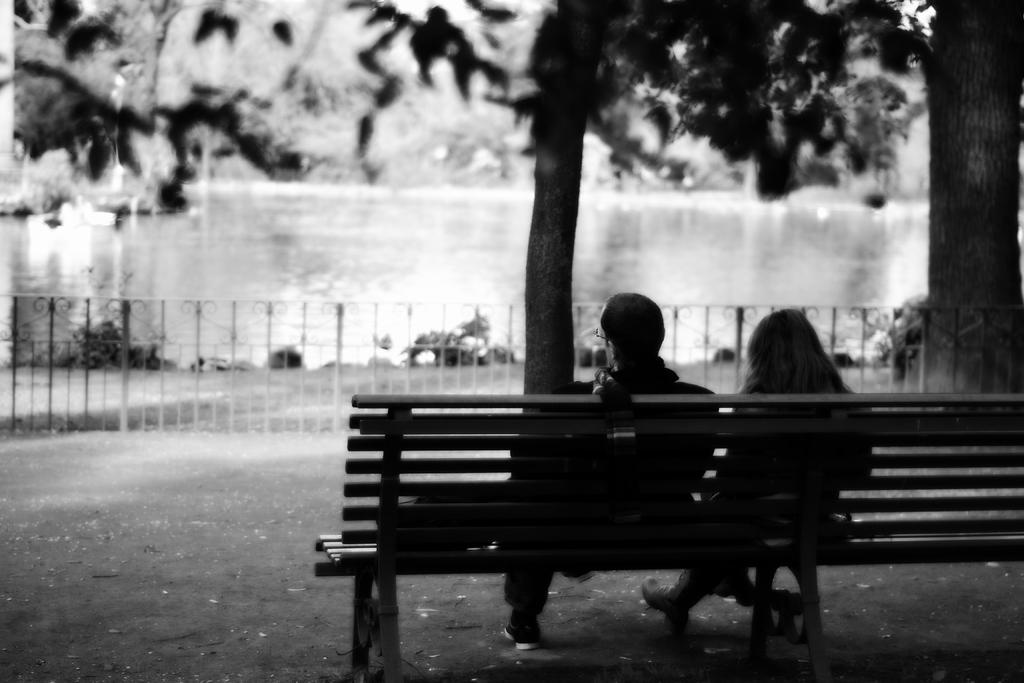How many people are in the image? There are two people in the image: a man and a woman. What are the man and woman doing in the image? The man and woman are sitting on a bench. What can be seen in the background of the image? There are trees, a lake, and plants in the background of the image. What type of badge is the man wearing in the image? There is no badge visible on the man in the image. How many muscles can be seen flexing on the woman's arm in the image? There are no muscles flexing on the woman's arm in the image; she is simply sitting on the bench. 